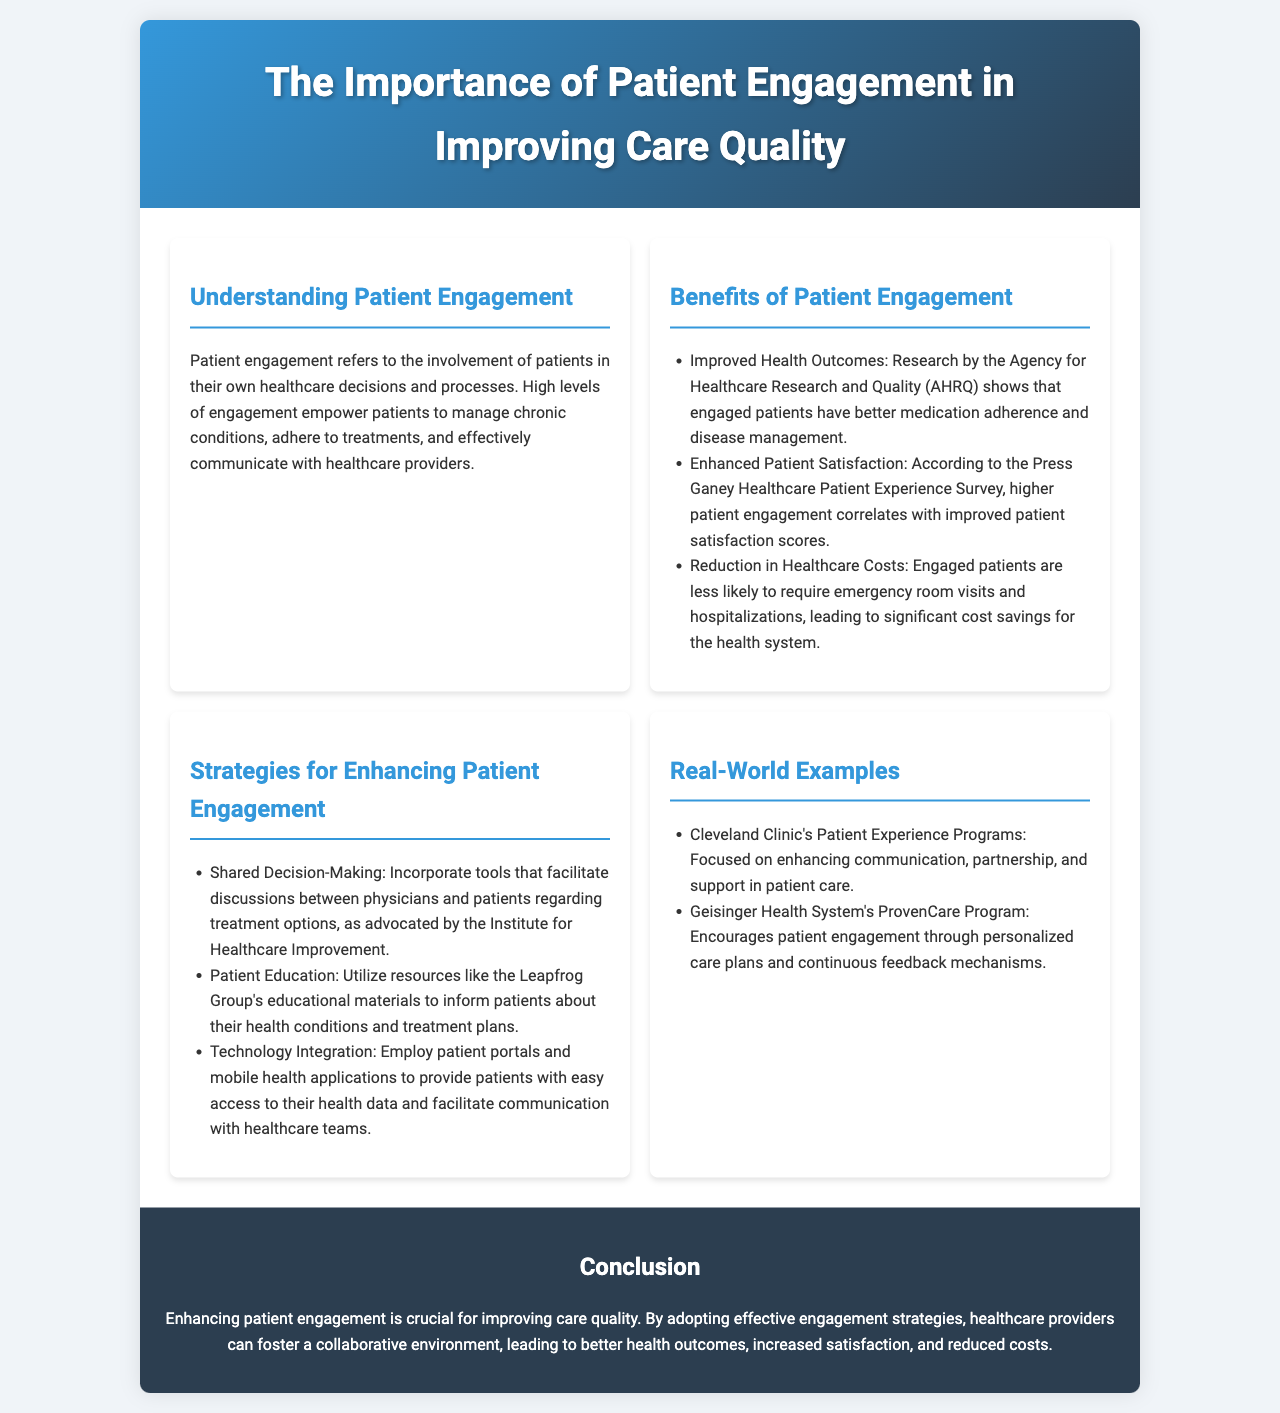What does patient engagement refer to? Patient engagement is defined in the document as the involvement of patients in their own healthcare decisions and processes.
Answer: Involvement in healthcare decisions What research source is mentioned regarding improved health outcomes? The document cites the Agency for Healthcare Research and Quality (AHRQ) as the source for research on health outcomes related to patient engagement.
Answer: Agency for Healthcare Research and Quality (AHRQ) What is one benefit of patient engagement related to satisfaction? The document states that higher patient engagement correlates with improved satisfaction scores according to the Press Ganey Healthcare Patient Experience Survey.
Answer: Improved patient satisfaction scores Name a strategy for enhancing patient engagement. The brochure lists various strategies; one is shared decision-making, which involves facilitating discussions between physicians and patients.
Answer: Shared decision-making Which health system is mentioned for its patient experience programs? The Cleveland Clinic is highlighted in the document for its focus on enhancing communication and support in patient care through its patient experience programs.
Answer: Cleveland Clinic What outcome is linked to engaged patients in terms of healthcare costs? The document mentions that engaged patients are less likely to require emergency room visits and hospitalizations, which leads to cost savings.
Answer: Reduction in healthcare costs What educational resource is suggested for patient education? The Leapfrog Group's educational materials are recommended in the document for informing patients about health conditions and treatment plans.
Answer: Leapfrog Group's educational materials What is the main conclusion of the brochure? The conclusion emphasizes that enhancing patient engagement is crucial for improving care quality and fostering a collaborative healthcare environment.
Answer: Enhancing patient engagement is crucial for improving care quality 